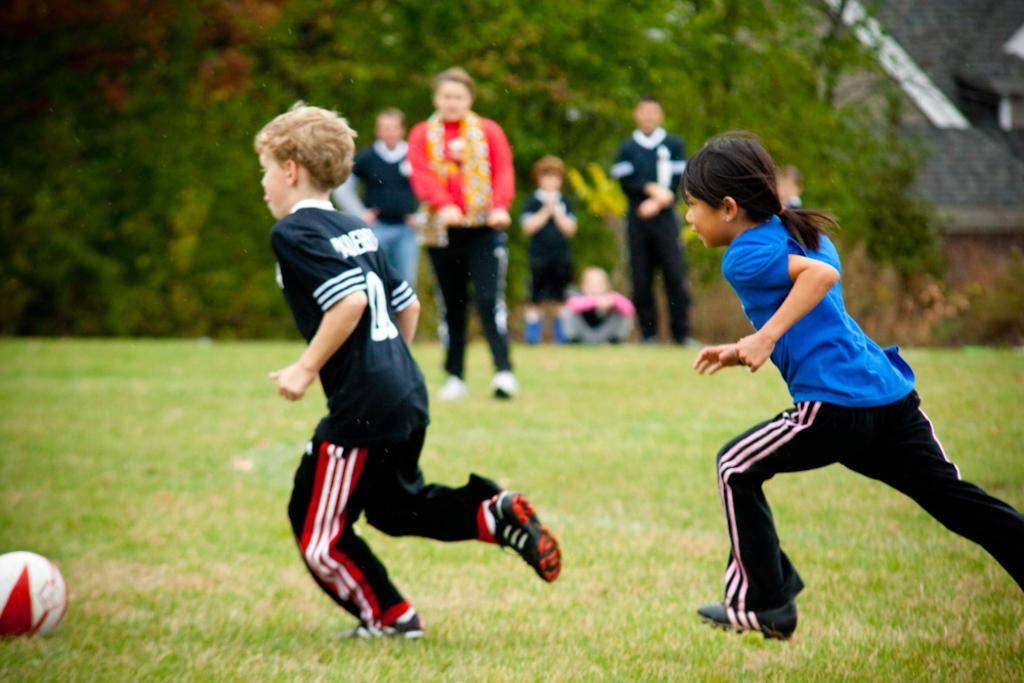What are the people in the image doing? The people in the image are standing on the ground. What are the children doing in the image? The children are running on the ground. What can be seen in the background of the image? There are buildings and trees in the background of the image. What object is on the ground in the image? There is a ball on the ground. Can you hear the woman laughing in the image? There is no woman or laughter present in the image; it only shows people and children standing and running on the ground, with a ball nearby. 